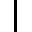Convert formula to latex. <formula><loc_0><loc_0><loc_500><loc_500>|</formula> 